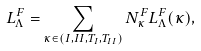<formula> <loc_0><loc_0><loc_500><loc_500>L _ { \Lambda } ^ { F } = \sum _ { \kappa \in ( I , I I , T _ { I } , T _ { I I } ) } N _ { \kappa } ^ { F } L _ { \Lambda } ^ { F } ( \kappa ) ,</formula> 